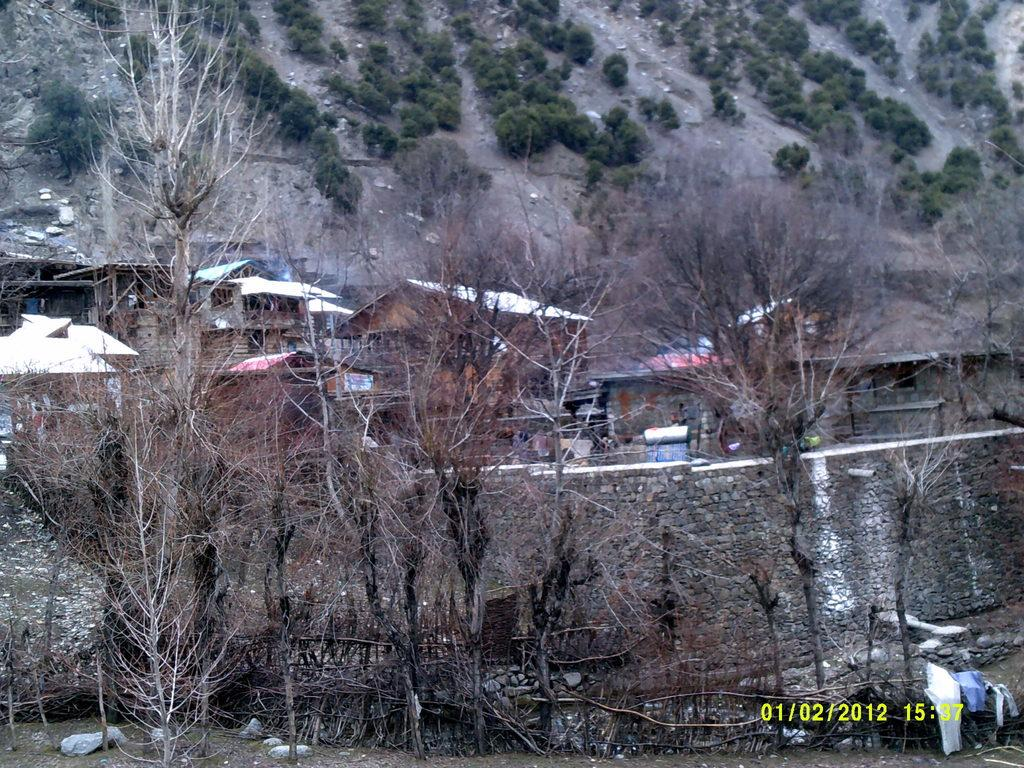What type of vegetation can be seen in the image? There are trees in the image. What type of structures are present in the image? There are houses in the image. What type of material is present in the image? There are stones in the image. What type of personal items can be seen in the image? There are clothes in the image. What is the condition of the trees in the image? There are dry trees in the image. What type of error can be seen in the image? There is no error present in the image. Can you see a bear in the image? There is no bear present in the image. 